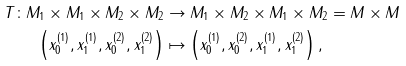Convert formula to latex. <formula><loc_0><loc_0><loc_500><loc_500>T \colon M _ { 1 } \times M _ { 1 } \times M _ { 2 } \times M _ { 2 } & \rightarrow M _ { 1 } \times M _ { 2 } \times M _ { 1 } \times M _ { 2 } = M \times M \\ \left ( x ^ { ( 1 ) } _ { 0 } , x ^ { ( 1 ) } _ { 1 } , x ^ { ( 2 ) } _ { 0 } , x ^ { ( 2 ) } _ { 1 } \right ) & \mapsto \left ( x ^ { ( 1 ) } _ { 0 } , x ^ { ( 2 ) } _ { 0 } , x ^ { ( 1 ) } _ { 1 } , x ^ { ( 2 ) } _ { 1 } \right ) ,</formula> 